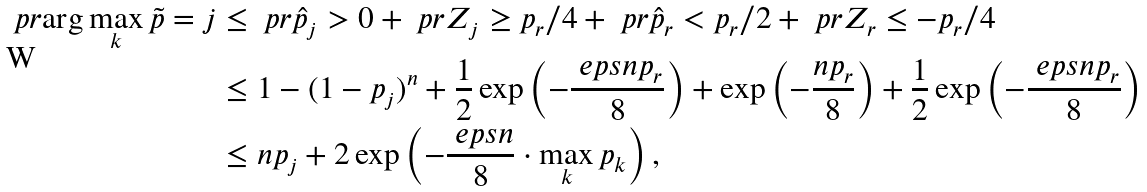<formula> <loc_0><loc_0><loc_500><loc_500>\ p r { \arg \max _ { k } \tilde { p } = j } & \leq \ p r { \hat { p } _ { j } > 0 } + \ p r { Z _ { j } \geq p _ { r } / 4 } + \ p r { \hat { p } _ { r } < p _ { r } / 2 } + \ p r { Z _ { r } \leq - p _ { r } / 4 } \\ & \leq 1 - ( 1 - p _ { j } ) ^ { n } + \frac { 1 } { 2 } \exp \left ( - \frac { \ e p s n p _ { r } } { 8 } \right ) + \exp \left ( - \frac { n p _ { r } } { 8 } \right ) + \frac { 1 } { 2 } \exp \left ( - \frac { \ e p s n p _ { r } } { 8 } \right ) \\ & \leq n p _ { j } + 2 \exp \left ( - \frac { \ e p s n } { 8 } \cdot \max _ { k } p _ { k } \right ) ,</formula> 